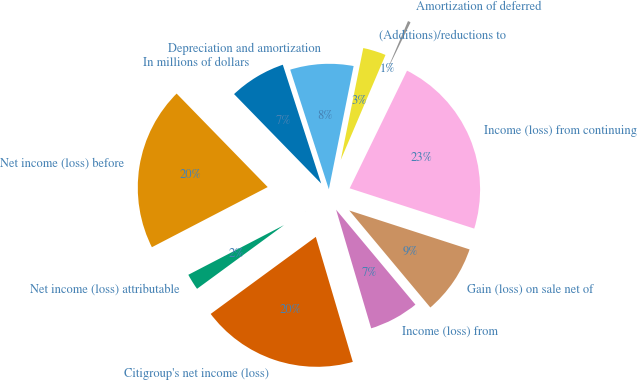Convert chart to OTSL. <chart><loc_0><loc_0><loc_500><loc_500><pie_chart><fcel>In millions of dollars<fcel>Net income (loss) before<fcel>Net income (loss) attributable<fcel>Citigroup's net income (loss)<fcel>Income (loss) from<fcel>Gain (loss) on sale net of<fcel>Income (loss) from continuing<fcel>Amortization of deferred<fcel>(Additions)/reductions to<fcel>Depreciation and amortization<nl><fcel>7.32%<fcel>20.33%<fcel>2.44%<fcel>19.51%<fcel>6.5%<fcel>8.94%<fcel>22.76%<fcel>0.81%<fcel>3.25%<fcel>8.13%<nl></chart> 